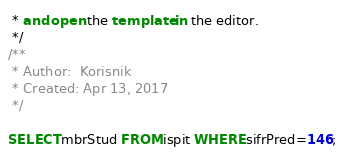Convert code to text. <code><loc_0><loc_0><loc_500><loc_500><_SQL_> * and open the template in the editor.
 */
/**
 * Author:  Korisnik
 * Created: Apr 13, 2017
 */

SELECT mbrStud FROM ispit WHERE sifrPred=146;</code> 